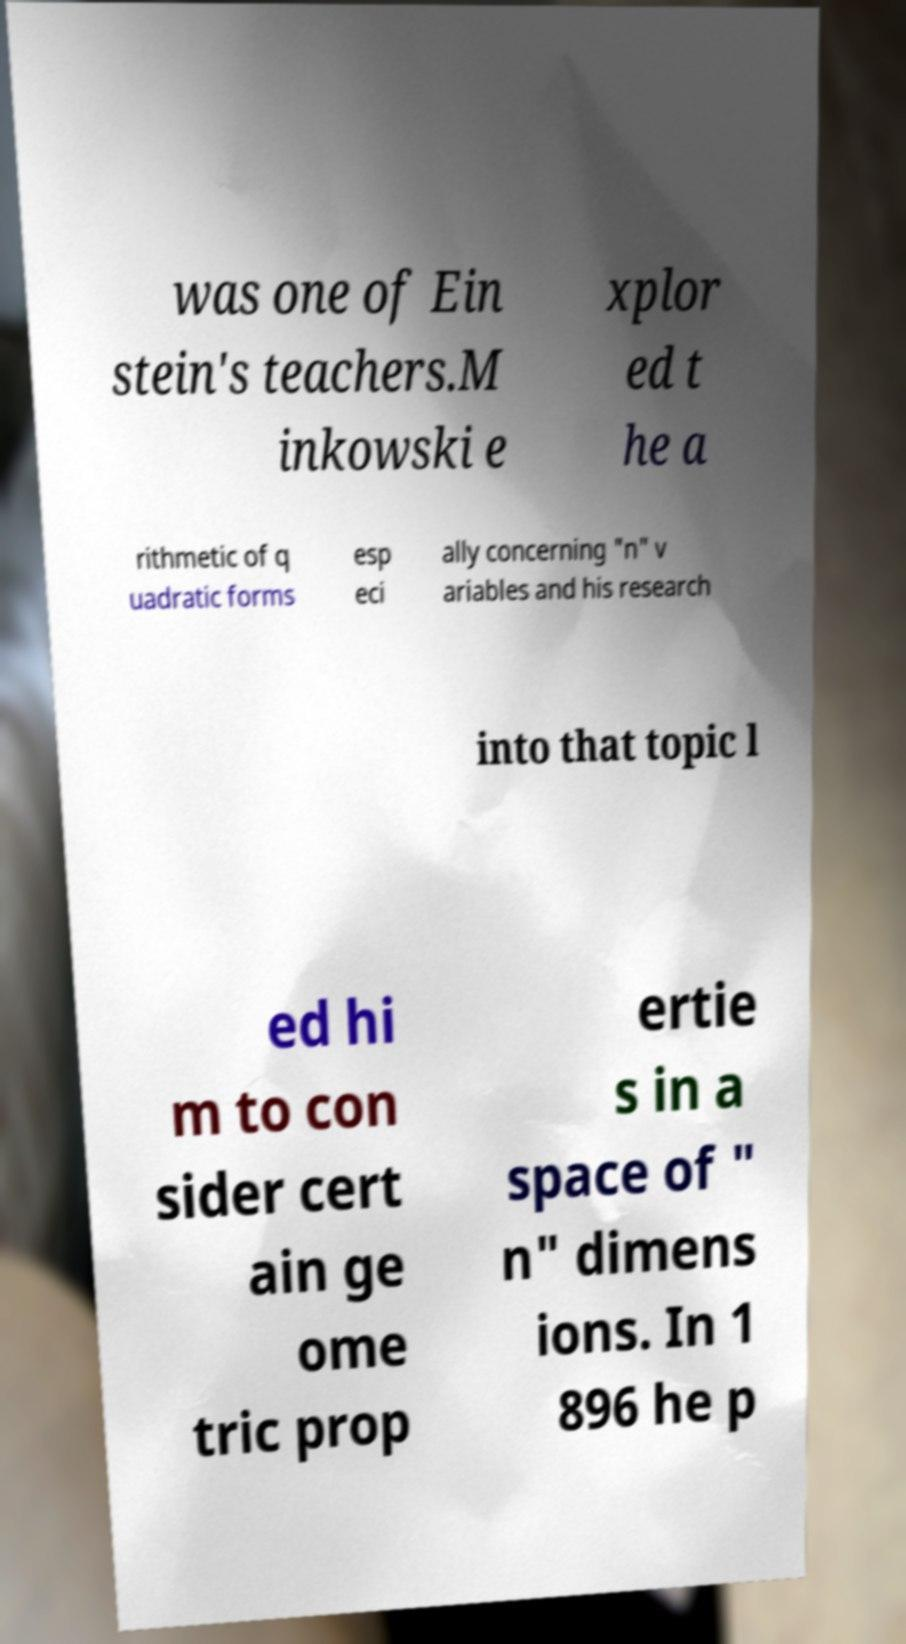What messages or text are displayed in this image? I need them in a readable, typed format. was one of Ein stein's teachers.M inkowski e xplor ed t he a rithmetic of q uadratic forms esp eci ally concerning "n" v ariables and his research into that topic l ed hi m to con sider cert ain ge ome tric prop ertie s in a space of " n" dimens ions. In 1 896 he p 